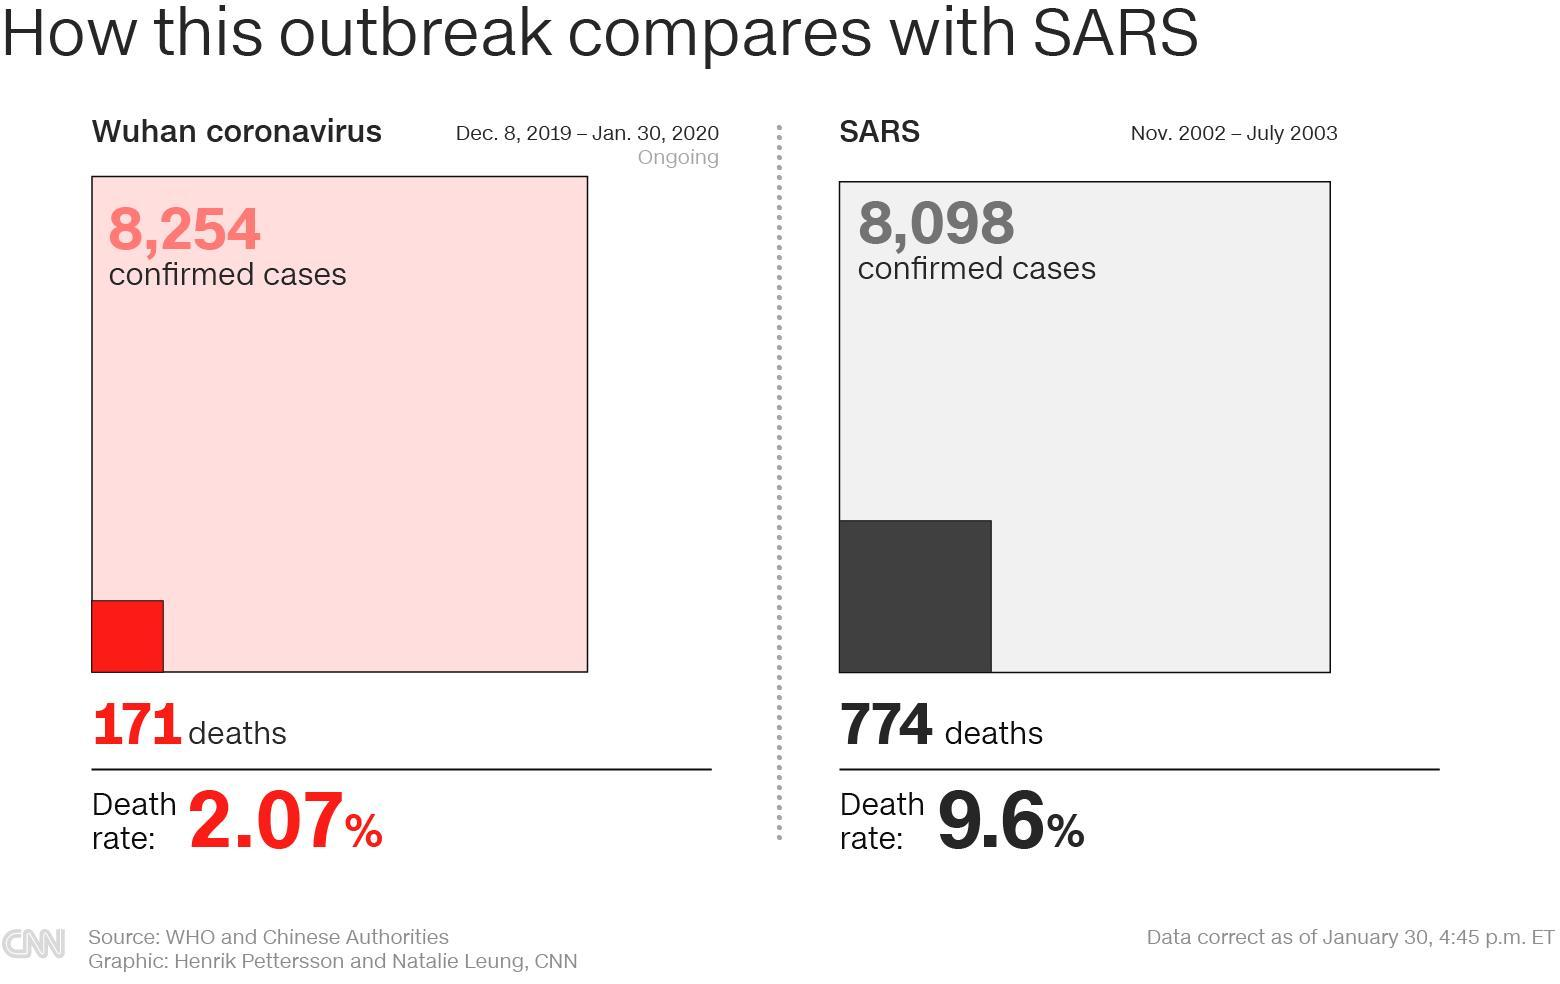During which time period, the SARS virus outbreak happened?
Answer the question with a short phrase. Nov. 2002 - July 2003 How many fatalities due to SARS virus were reported in China? 774 What is the total number of confirmed COVID-19 cases reported in Wuhan, China as of January 30, 2020? 8,254 How many fatalities due to COVID-19 were reported in China as of January 30, 2020? 171 When did the COVID-19 outbreak started? Dec.8, 2019 What is the case fatality rate of SARS? 9.6% What is the case fatality rate of COVID-19? 2.07% 